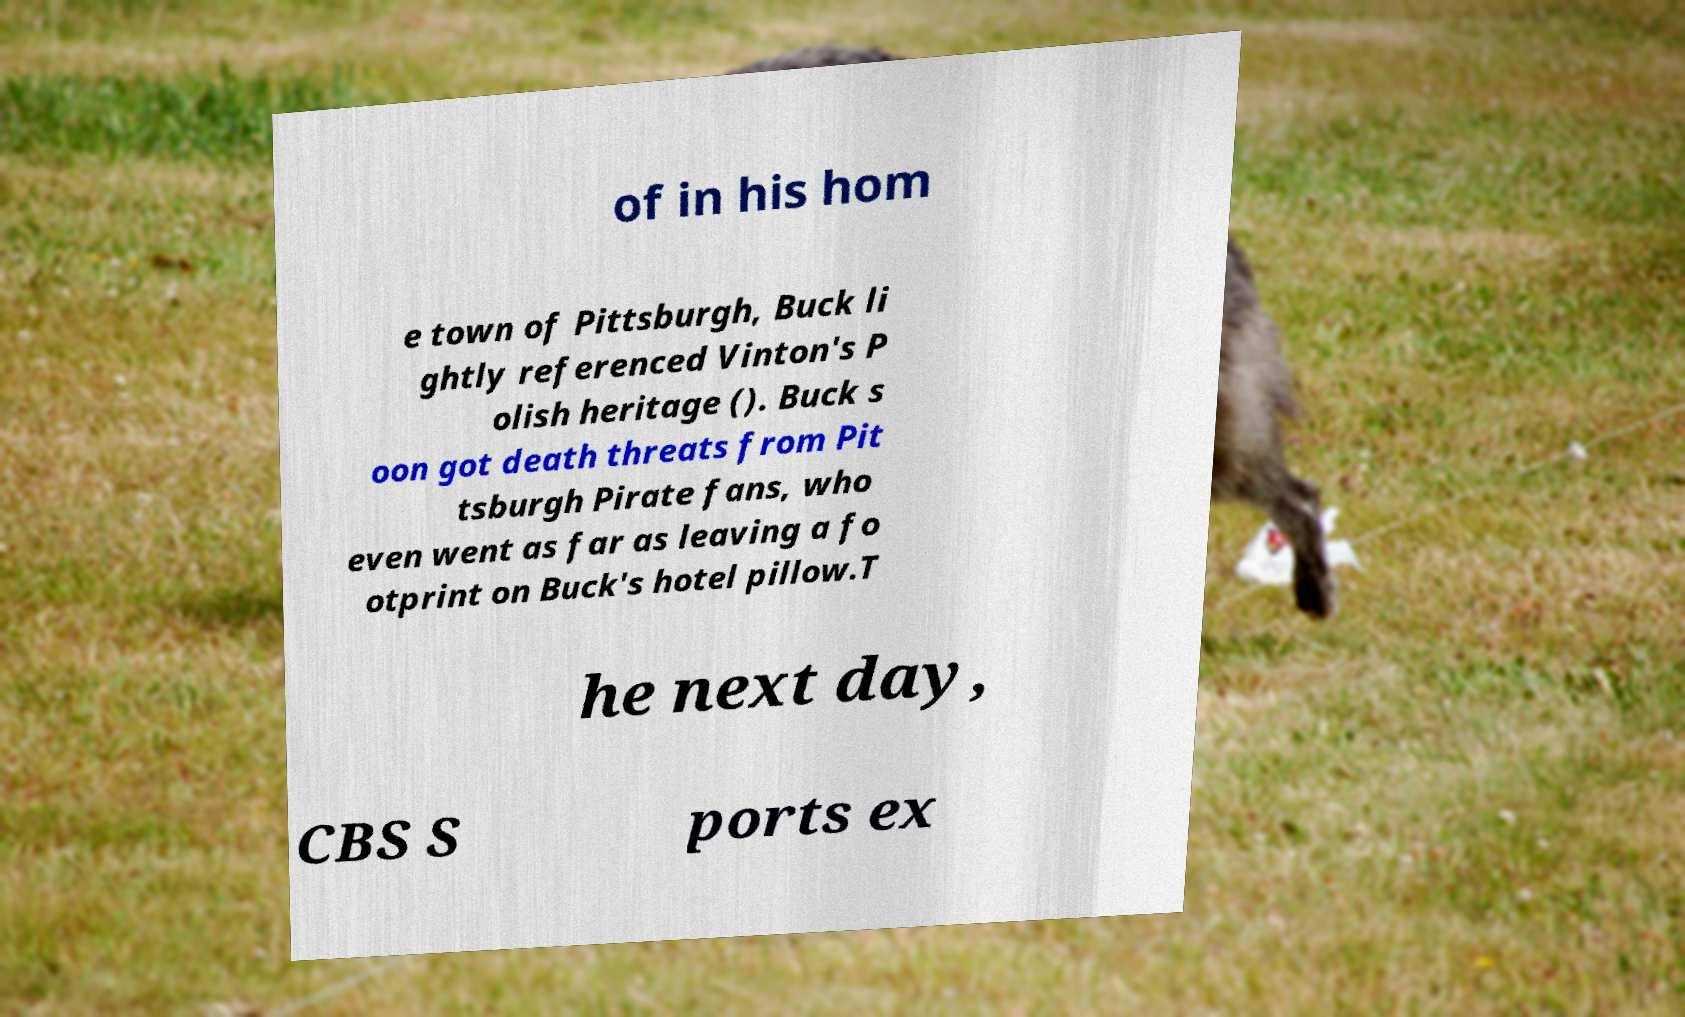I need the written content from this picture converted into text. Can you do that? of in his hom e town of Pittsburgh, Buck li ghtly referenced Vinton's P olish heritage (). Buck s oon got death threats from Pit tsburgh Pirate fans, who even went as far as leaving a fo otprint on Buck's hotel pillow.T he next day, CBS S ports ex 